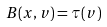<formula> <loc_0><loc_0><loc_500><loc_500>B ( x , v ) = \tau ( v )</formula> 